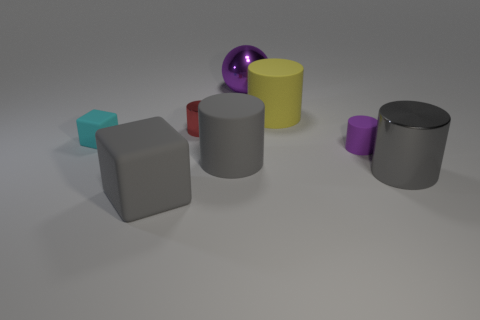Subtract 2 cylinders. How many cylinders are left? 3 Subtract all small purple matte cylinders. How many cylinders are left? 4 Subtract all yellow cylinders. How many cylinders are left? 4 Subtract all green cylinders. Subtract all cyan spheres. How many cylinders are left? 5 Add 2 tiny red metallic blocks. How many objects exist? 10 Subtract all spheres. How many objects are left? 7 Add 4 purple spheres. How many purple spheres exist? 5 Subtract 1 gray cylinders. How many objects are left? 7 Subtract all blue cubes. Subtract all purple balls. How many objects are left? 7 Add 6 gray objects. How many gray objects are left? 9 